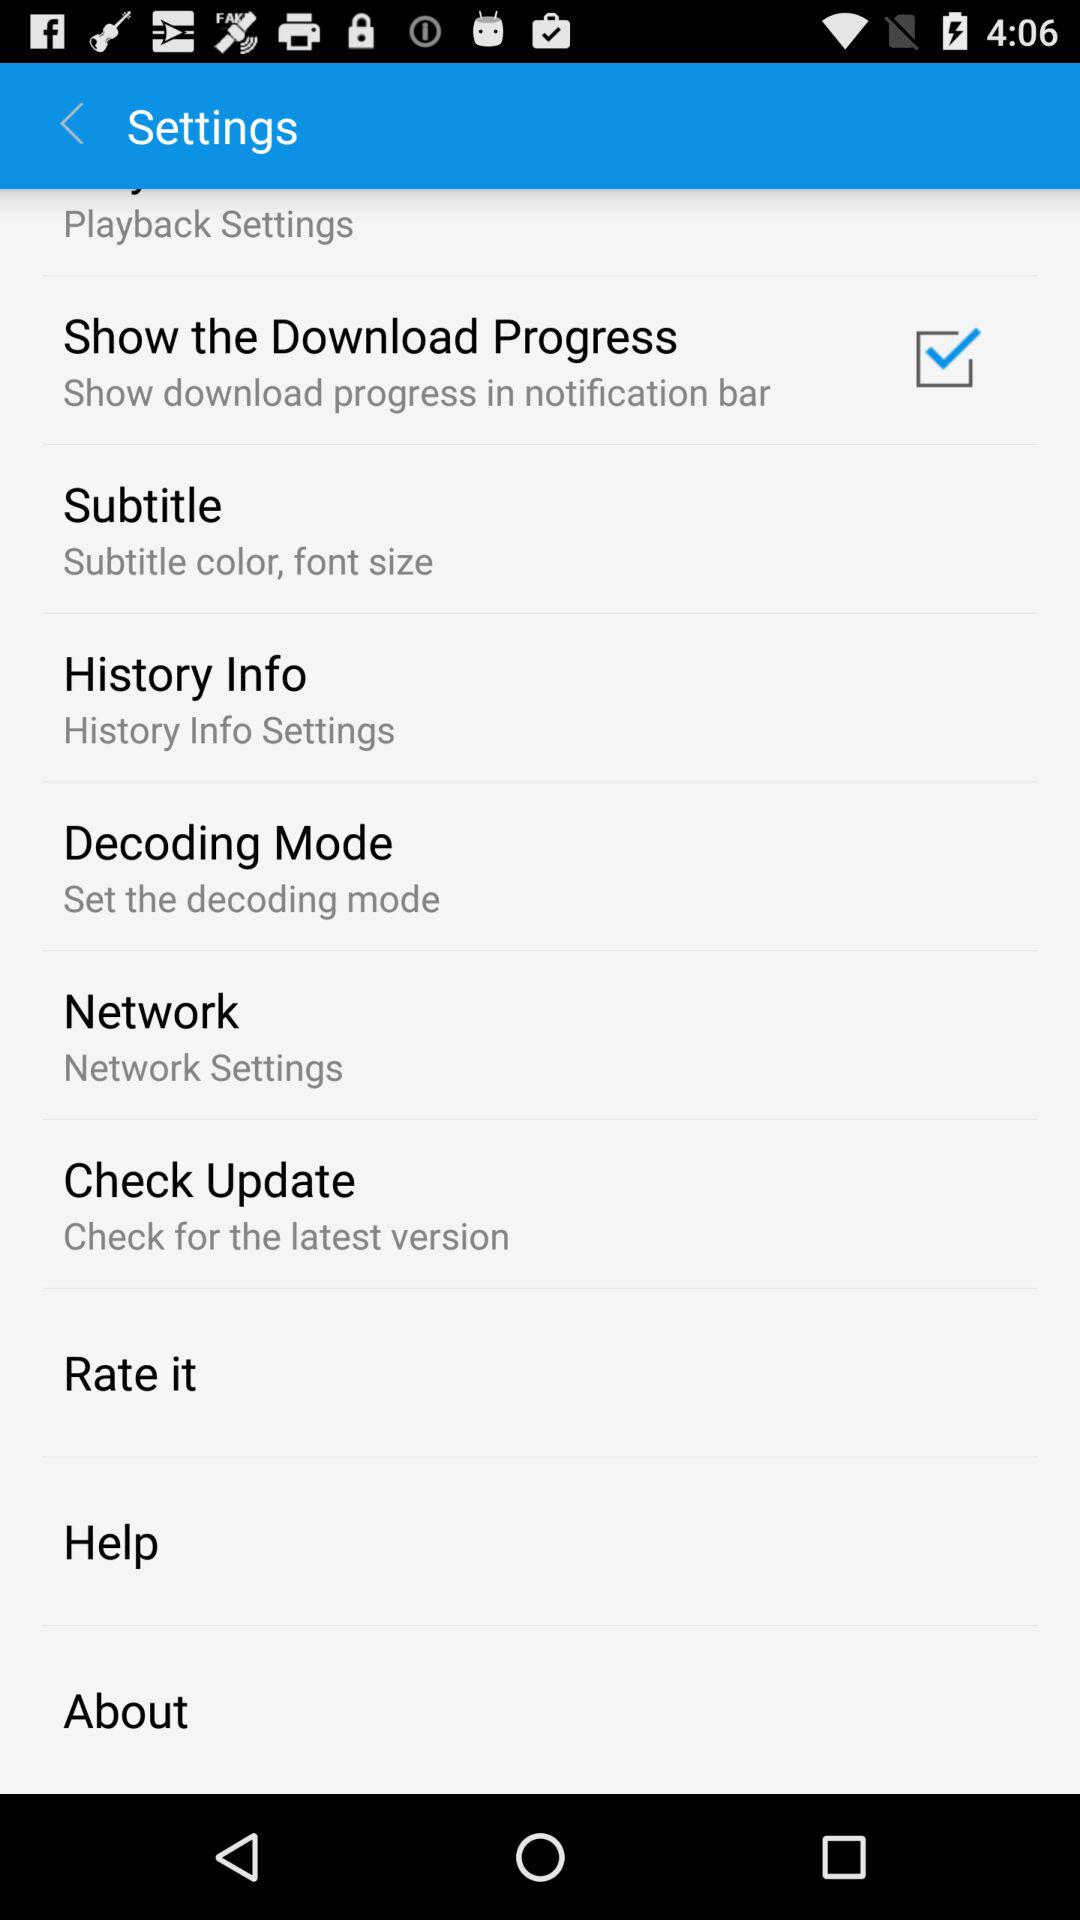Which option is selected in the subtitle setting? The selected options are subtitle color and font size. 